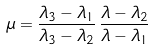<formula> <loc_0><loc_0><loc_500><loc_500>\mu = \frac { \lambda _ { 3 } - \lambda _ { 1 } } { \lambda _ { 3 } - \lambda _ { 2 } } \, \frac { \lambda - \lambda _ { 2 } } { \lambda - \lambda _ { 1 } }</formula> 